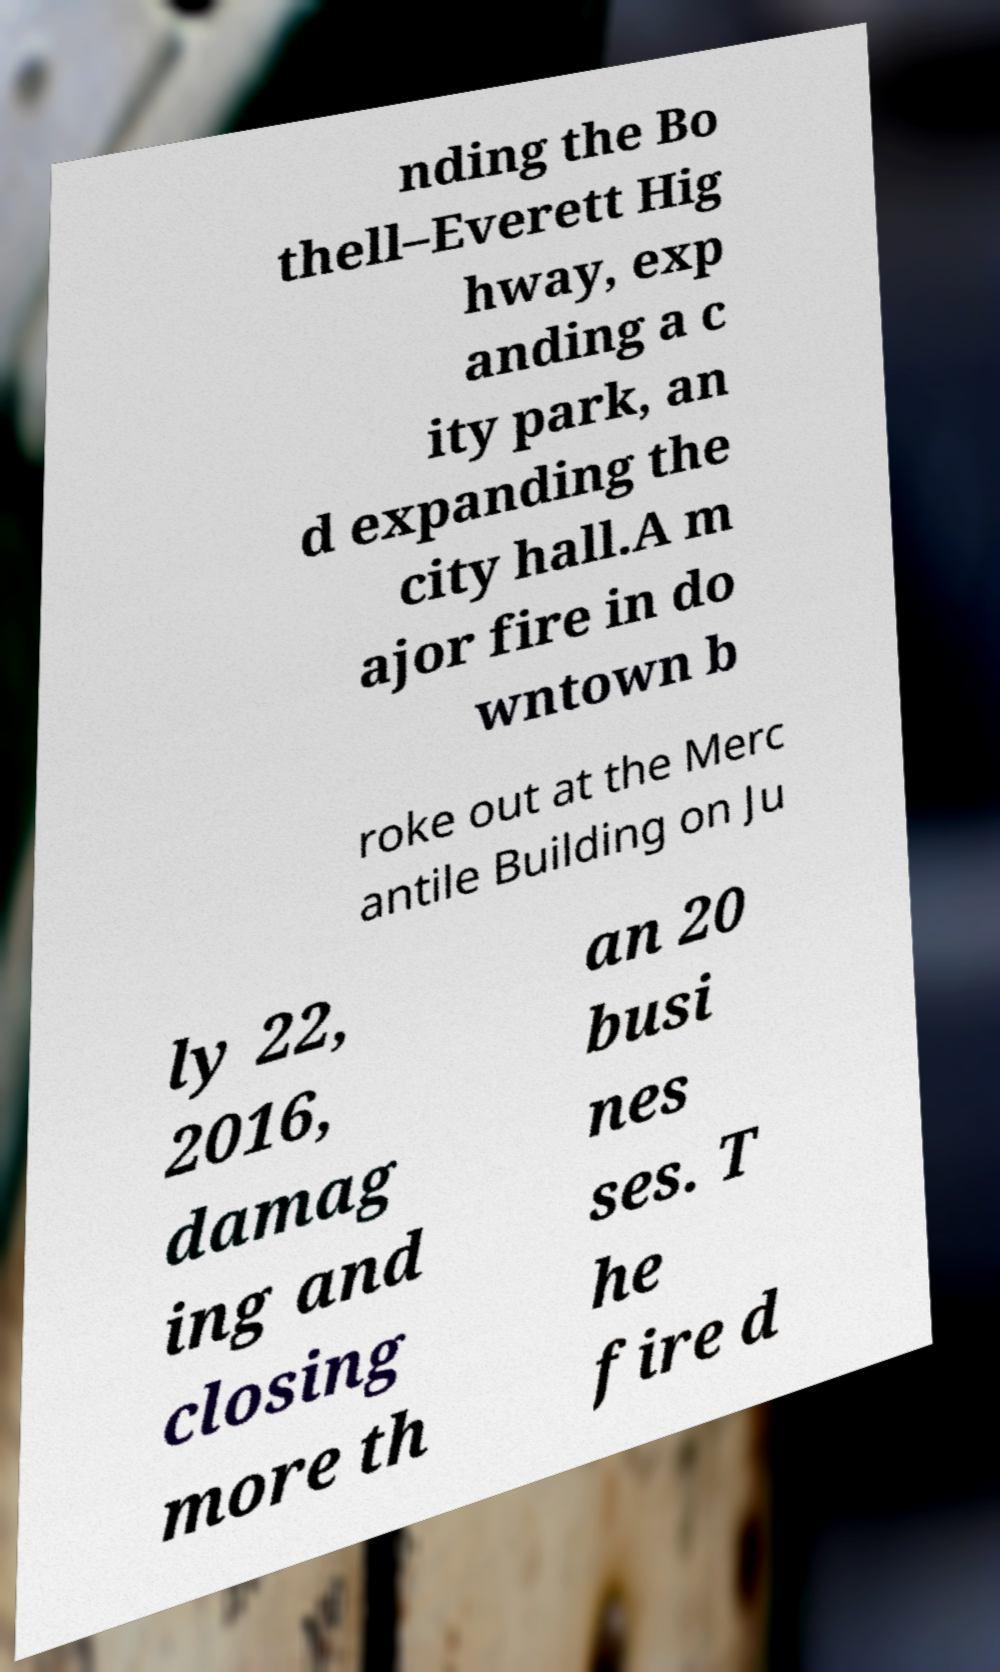Please read and relay the text visible in this image. What does it say? nding the Bo thell–Everett Hig hway, exp anding a c ity park, an d expanding the city hall.A m ajor fire in do wntown b roke out at the Merc antile Building on Ju ly 22, 2016, damag ing and closing more th an 20 busi nes ses. T he fire d 